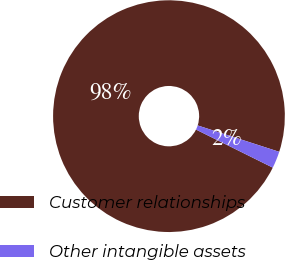Convert chart. <chart><loc_0><loc_0><loc_500><loc_500><pie_chart><fcel>Customer relationships<fcel>Other intangible assets<nl><fcel>97.65%<fcel>2.35%<nl></chart> 